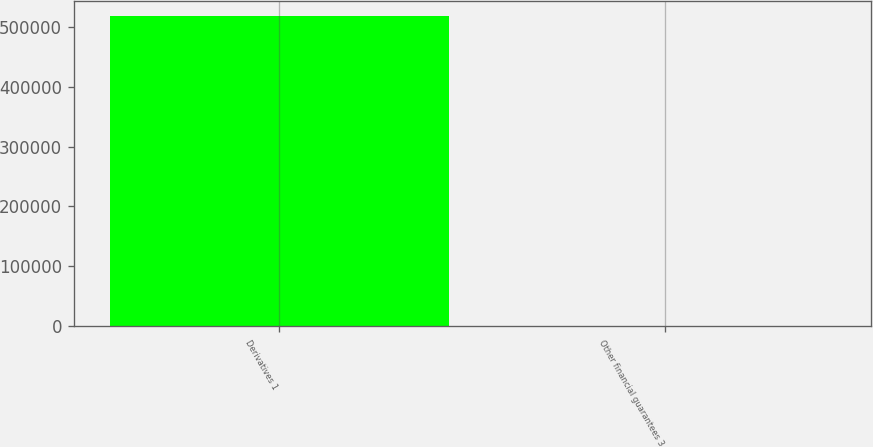Convert chart to OTSL. <chart><loc_0><loc_0><loc_500><loc_500><bar_chart><fcel>Derivatives 1<fcel>Other financial guarantees 3<nl><fcel>517634<fcel>1361<nl></chart> 